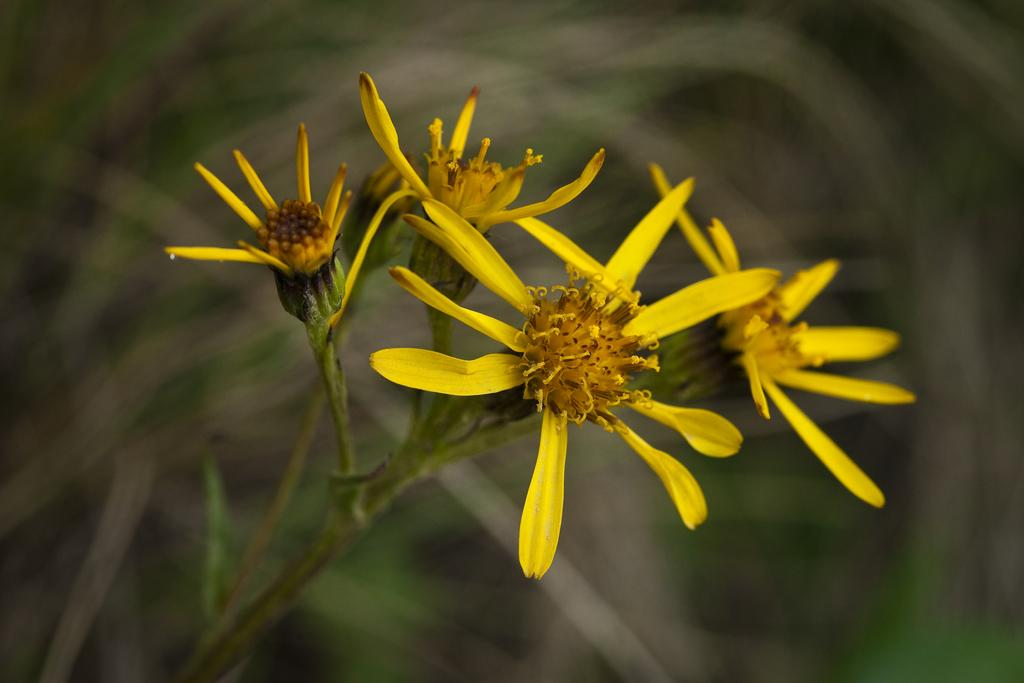What is the main subject of the image? The main subject of the image is a stem. What can be seen on the stem? The stem has yellow flowers. Can you describe the background of the image? The background of the image is blurred. How old is the baby in the image? There is no baby present in the image; it features a stem with yellow flowers. What type of winter clothing is the person wearing in the image? There is no person or winter clothing present in the image. 